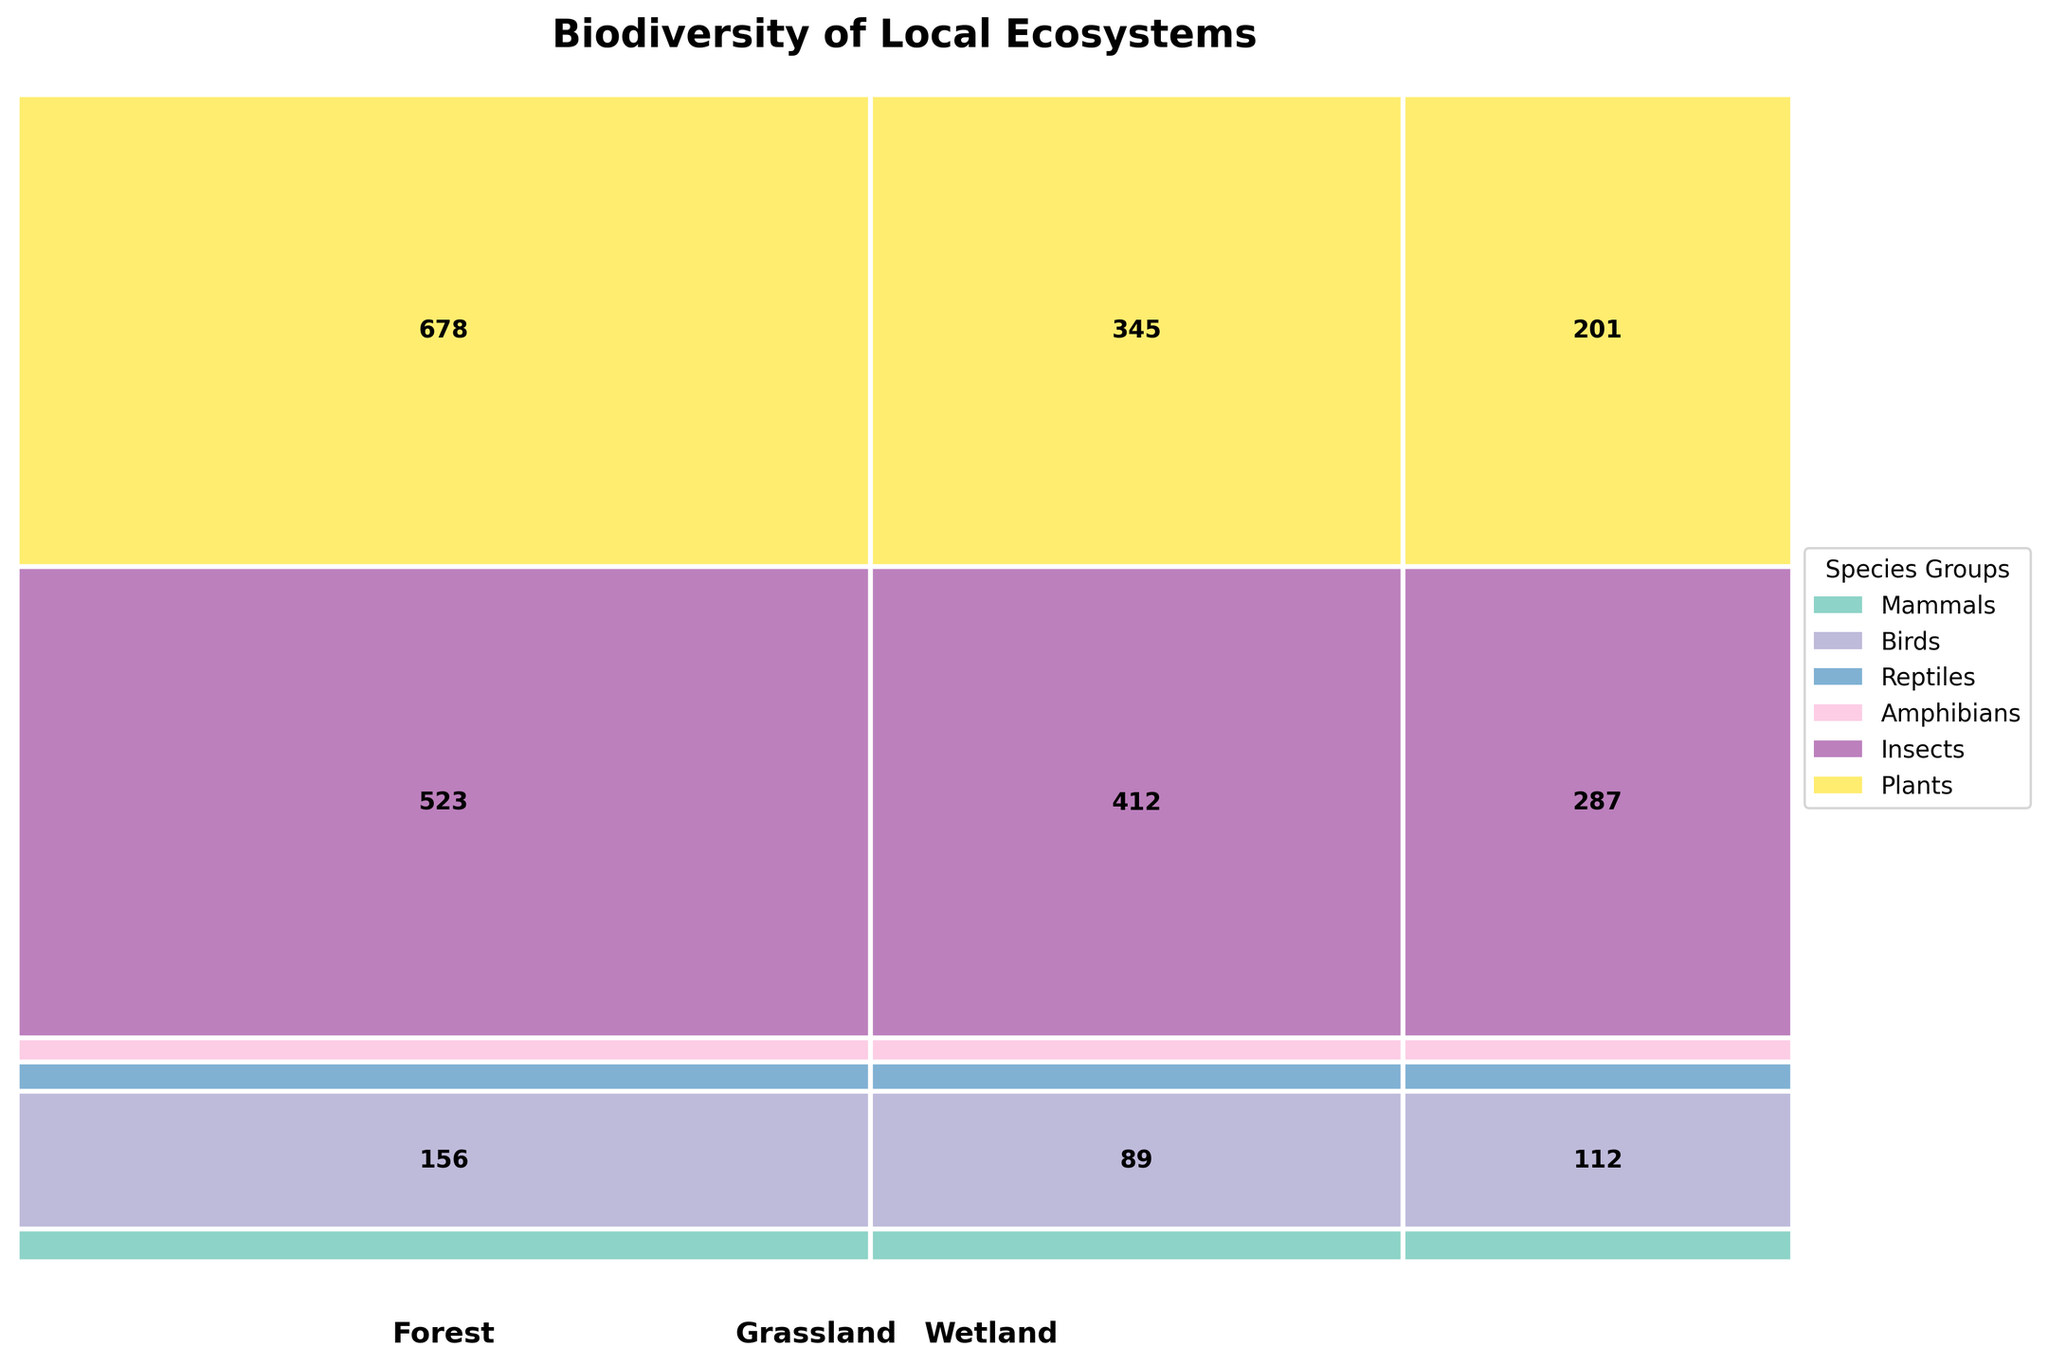What is the title of the plot? The title of the plot is found at the upper section, often in larger font size and bolded. In this mosaic plot, it reads 'Biodiversity of Local Ecosystems'.
Answer: Biodiversity of Local Ecosystems Which species group has the largest total number of species? By observing the total area of rectangles corresponding to each species group, the group with the largest coverage in the plot represents the largest total number of species. In this case, 'Plants' occupy the largest area.
Answer: Plants Compare the number of bird species in wetland to those in forest. Which is greater? Compare the sizes of rectangles for 'Birds' in 'Wetland' and 'Forest'. The rectangle corresponding to 'Birds' in 'Forest' shows a larger dimension in comparison to 'Birds' in 'Wetland', hence the number of bird species is greater in the forest.
Answer: Birds in Forest What is the proportion of insects in wetland relative to the total number of insect species? The proportion can be calculated by observing the area corresponding to 'Insects' in 'Wetland' and the total area for 'Insects'.
Answer: 287/1222 (approximately 23.5%) Which habitat type has the highest number of species across all species groups? The total area corresponding to each habitat type indicates the number of species. The largest area corresponds to 'Forest'.
Answer: Forest What is the combined number of mammal species in forest and grassland? Sum the values of mammal species in forest and grassland, which are clearly denoted within the plot.
Answer: 42 + 28 = 70 Are there more amphibian species in forest or the combined number of amphibian species in grassland and wetland? Compare the number of amphibian species in the forest (22) to the combined number in grassland and wetland (9 + 31 = 40).
Answer: Combined number in Grassland and Wetland How does the number of reptile species in grassland compare to that in wetland? Compare the rectangles for 'Reptiles' in 'Grassland' and 'Wetland'. The number of reptile species in grassland (25) is greater than that in wetland (18).
Answer: Greater in Grassland What is the smallest species group by number in grassland? Look for the smallest rectangle within the 'Grassland' section. 'Amphibians' have the smallest area.
Answer: Amphibians Which group has the most varied distribution across different habitat types? Assess the differences in the size of rectangles for each species group across the habitat types. 'Birds' show significant variation across forest, grassland, and wetland.
Answer: Birds 